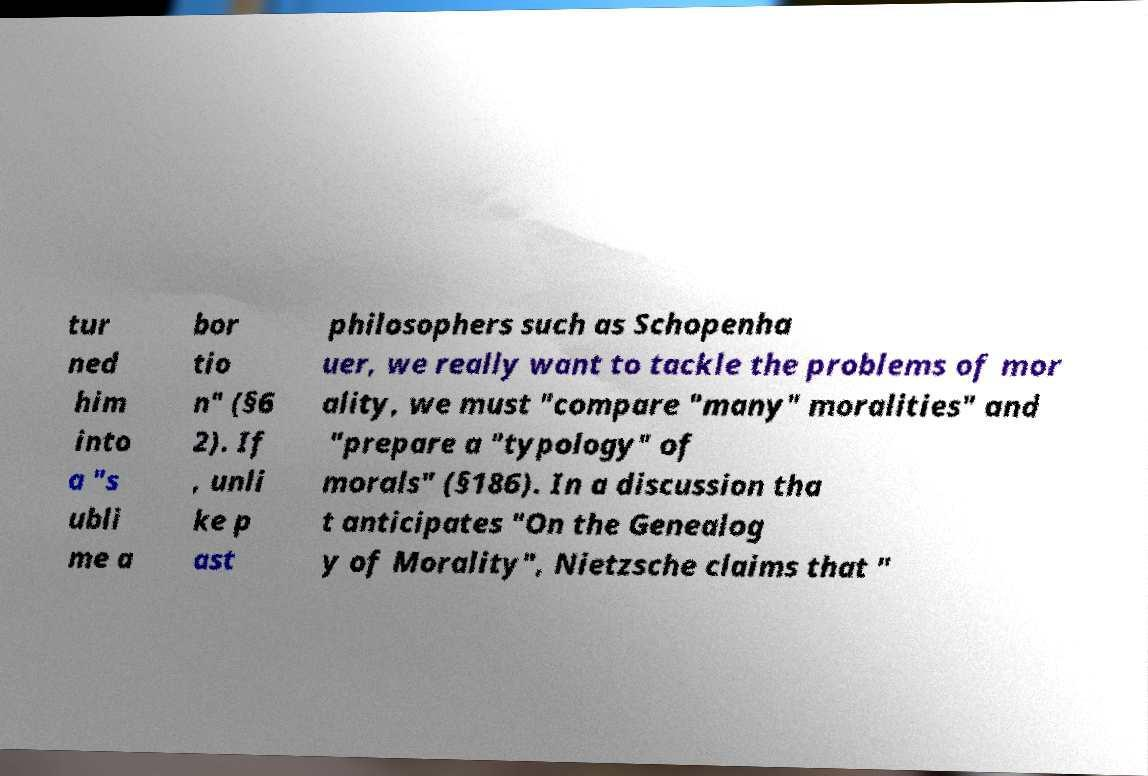Could you extract and type out the text from this image? tur ned him into a "s ubli me a bor tio n" (§6 2). If , unli ke p ast philosophers such as Schopenha uer, we really want to tackle the problems of mor ality, we must "compare "many" moralities" and "prepare a "typology" of morals" (§186). In a discussion tha t anticipates "On the Genealog y of Morality", Nietzsche claims that " 